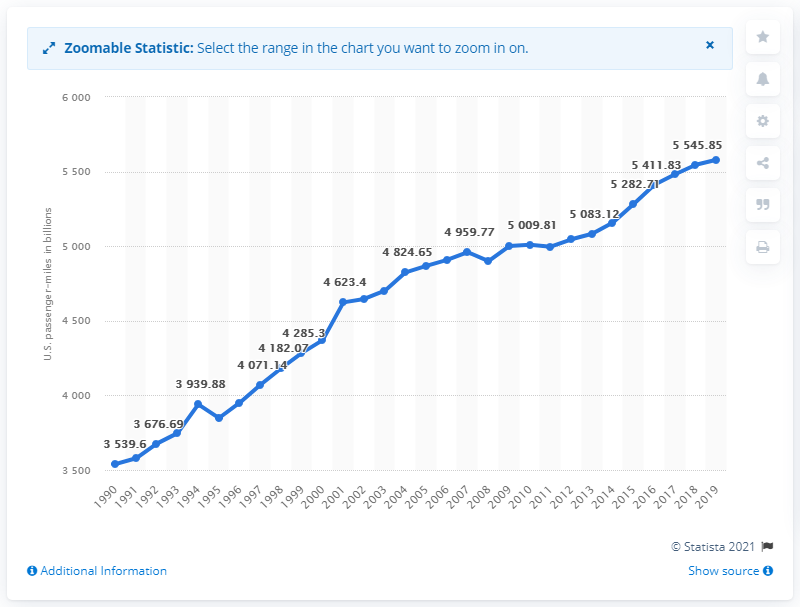Draw attention to some important aspects in this diagram. In 2019, Americans traveled a total of 55,79.13 miles on highways. 